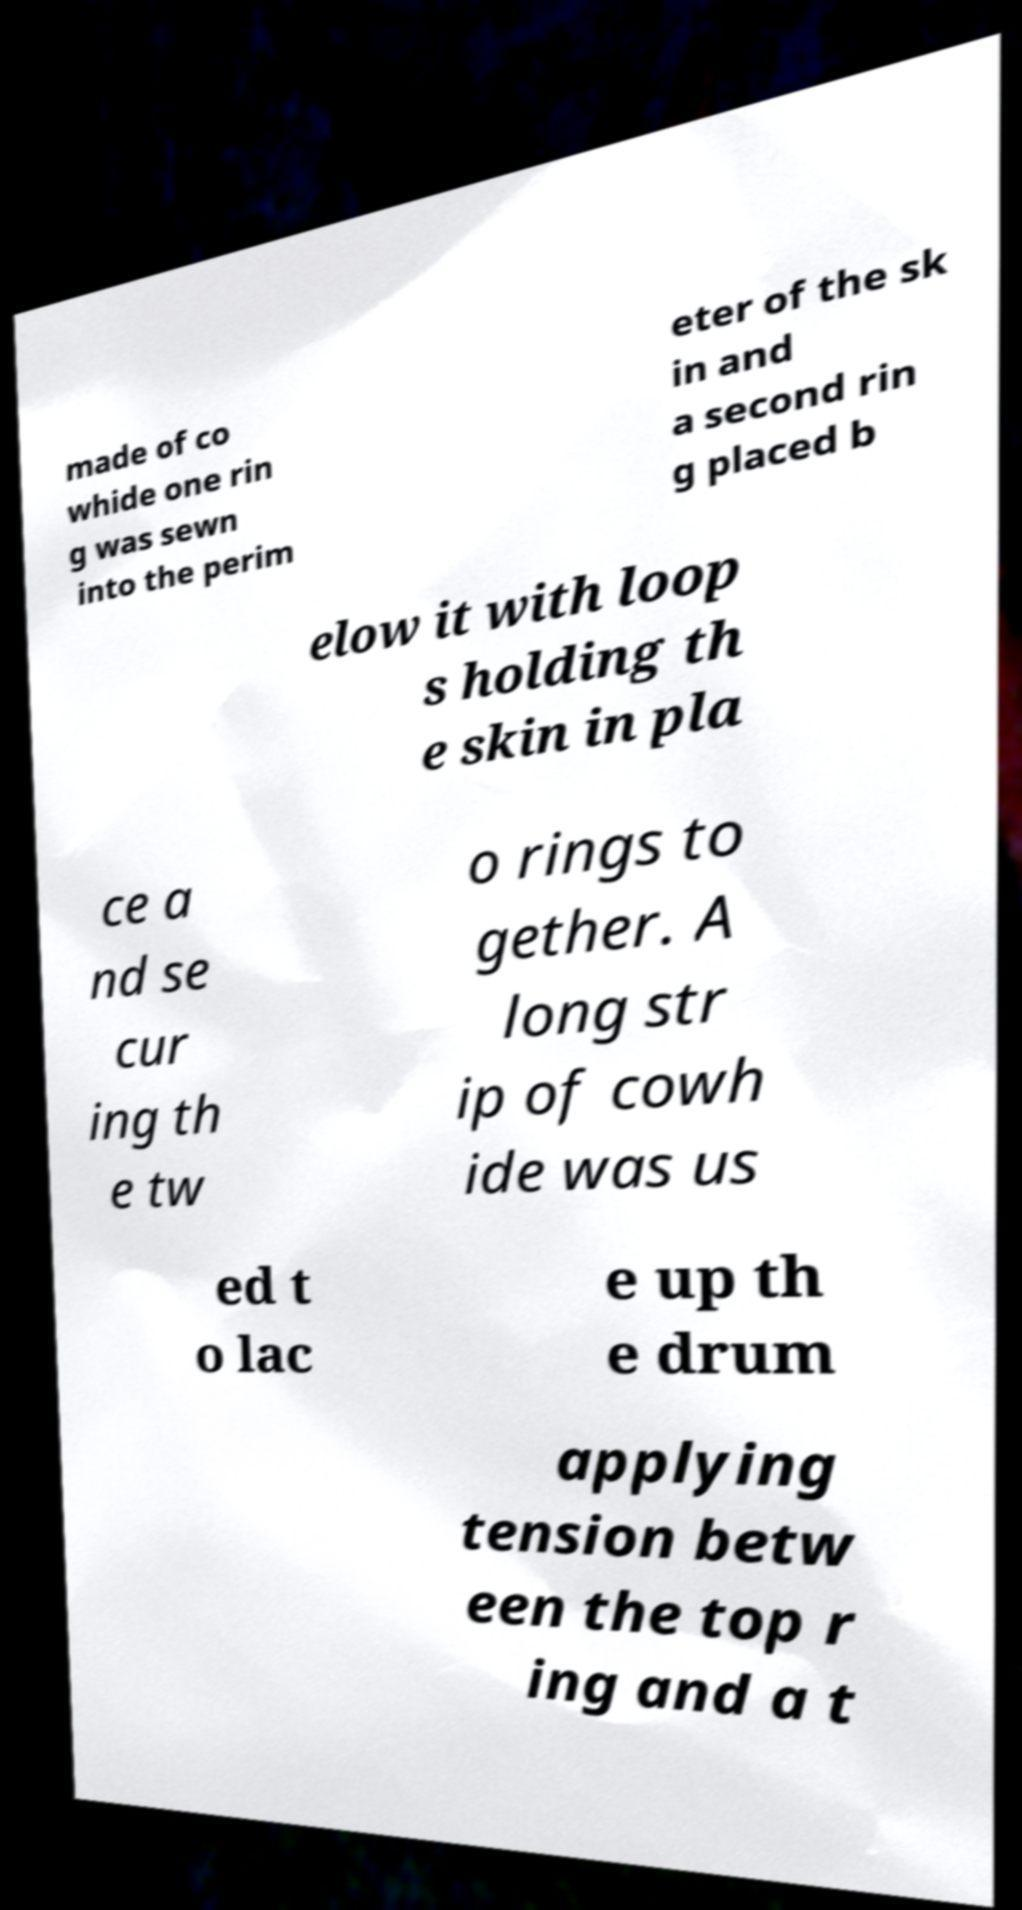What messages or text are displayed in this image? I need them in a readable, typed format. made of co whide one rin g was sewn into the perim eter of the sk in and a second rin g placed b elow it with loop s holding th e skin in pla ce a nd se cur ing th e tw o rings to gether. A long str ip of cowh ide was us ed t o lac e up th e drum applying tension betw een the top r ing and a t 